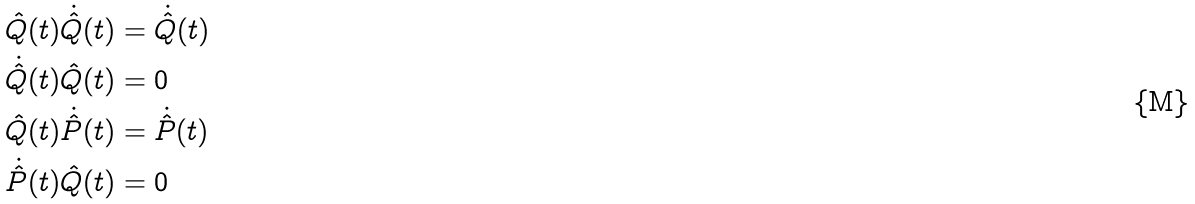Convert formula to latex. <formula><loc_0><loc_0><loc_500><loc_500>& \hat { Q } ( t ) \dot { \hat { Q } } ( t ) = \dot { \hat { Q } } ( t ) \\ & \dot { \hat { Q } } ( t ) \hat { Q } ( t ) = 0 \\ & \hat { Q } ( t ) \dot { \hat { P } } ( t ) = \dot { \hat { P } } ( t ) \\ & \dot { \hat { P } } ( t ) \hat { Q } ( t ) = 0</formula> 